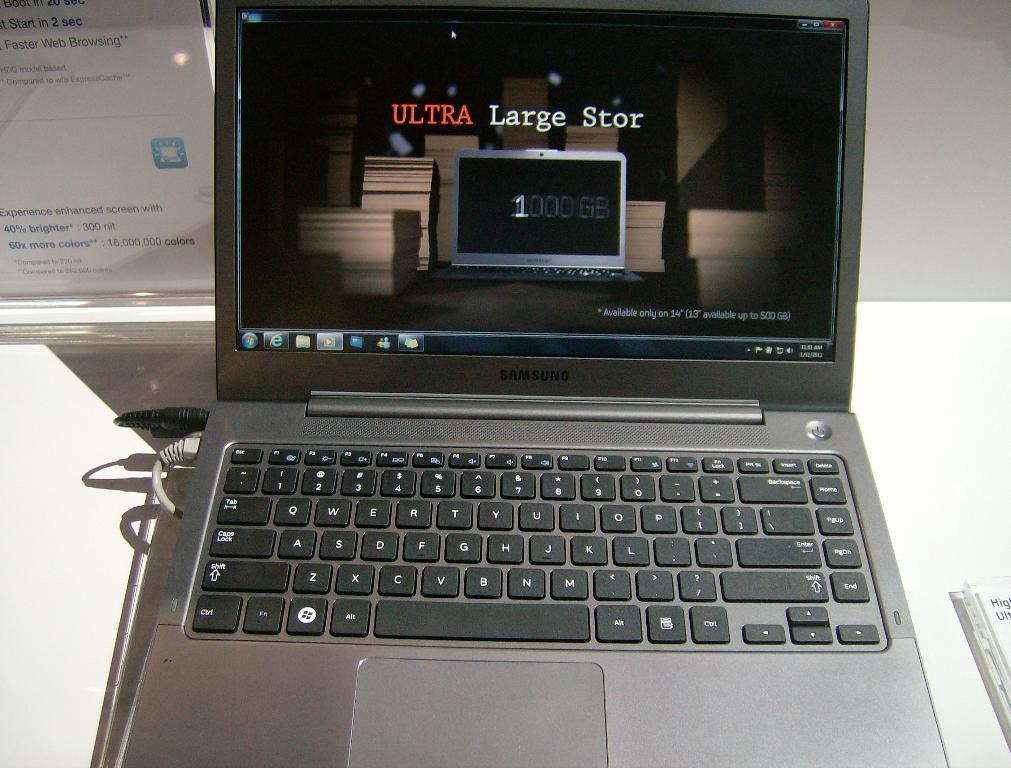<image>
Describe the image concisely. A computer screen says ULTRA Large Stor above the number 1. 